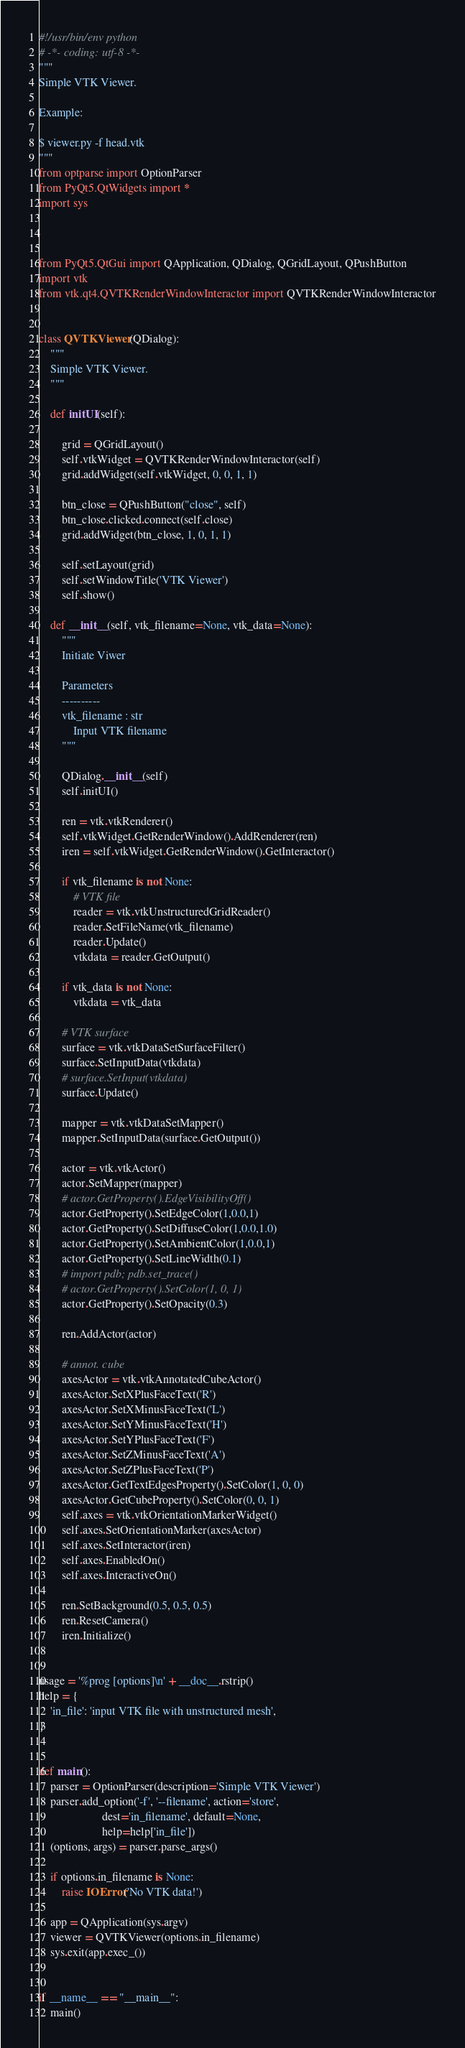Convert code to text. <code><loc_0><loc_0><loc_500><loc_500><_Python_>#!/usr/bin/env python
# -*- coding: utf-8 -*-
"""
Simple VTK Viewer.

Example:

$ viewer.py -f head.vtk
"""
from optparse import OptionParser
from PyQt5.QtWidgets import *
import sys



from PyQt5.QtGui import QApplication, QDialog, QGridLayout, QPushButton
import vtk
from vtk.qt4.QVTKRenderWindowInteractor import QVTKRenderWindowInteractor


class QVTKViewer(QDialog):
    """
    Simple VTK Viewer.
    """

    def initUI(self):

        grid = QGridLayout()
        self.vtkWidget = QVTKRenderWindowInteractor(self)
        grid.addWidget(self.vtkWidget, 0, 0, 1, 1)

        btn_close = QPushButton("close", self)
        btn_close.clicked.connect(self.close)
        grid.addWidget(btn_close, 1, 0, 1, 1)

        self.setLayout(grid)
        self.setWindowTitle('VTK Viewer')
        self.show()

    def __init__(self, vtk_filename=None, vtk_data=None):
        """
        Initiate Viwer

        Parameters
        ----------
        vtk_filename : str
            Input VTK filename
        """

        QDialog.__init__(self)
        self.initUI()

        ren = vtk.vtkRenderer()
        self.vtkWidget.GetRenderWindow().AddRenderer(ren)
        iren = self.vtkWidget.GetRenderWindow().GetInteractor()

        if vtk_filename is not None:
            # VTK file
            reader = vtk.vtkUnstructuredGridReader()
            reader.SetFileName(vtk_filename)
            reader.Update()
            vtkdata = reader.GetOutput()

        if vtk_data is not None:
            vtkdata = vtk_data

        # VTK surface
        surface = vtk.vtkDataSetSurfaceFilter()
        surface.SetInputData(vtkdata)
        # surface.SetInput(vtkdata)
        surface.Update()

        mapper = vtk.vtkDataSetMapper()
        mapper.SetInputData(surface.GetOutput())

        actor = vtk.vtkActor()
        actor.SetMapper(mapper)
        # actor.GetProperty().EdgeVisibilityOff()
        actor.GetProperty().SetEdgeColor(1,0.0,1)
        actor.GetProperty().SetDiffuseColor(1,0.0,1.0)
        actor.GetProperty().SetAmbientColor(1,0.0,1)
        actor.GetProperty().SetLineWidth(0.1)
        # import pdb; pdb.set_trace()
        # actor.GetProperty().SetColor(1, 0, 1)
        actor.GetProperty().SetOpacity(0.3)

        ren.AddActor(actor)

        # annot. cube
        axesActor = vtk.vtkAnnotatedCubeActor()
        axesActor.SetXPlusFaceText('R')
        axesActor.SetXMinusFaceText('L')
        axesActor.SetYMinusFaceText('H')
        axesActor.SetYPlusFaceText('F')
        axesActor.SetZMinusFaceText('A')
        axesActor.SetZPlusFaceText('P')
        axesActor.GetTextEdgesProperty().SetColor(1, 0, 0)
        axesActor.GetCubeProperty().SetColor(0, 0, 1)
        self.axes = vtk.vtkOrientationMarkerWidget()
        self.axes.SetOrientationMarker(axesActor)
        self.axes.SetInteractor(iren)
        self.axes.EnabledOn()
        self.axes.InteractiveOn()

        ren.SetBackground(0.5, 0.5, 0.5)
        ren.ResetCamera()
        iren.Initialize()


usage = '%prog [options]\n' + __doc__.rstrip()
help = {
    'in_file': 'input VTK file with unstructured mesh',
}


def main():
    parser = OptionParser(description='Simple VTK Viewer')
    parser.add_option('-f', '--filename', action='store',
                      dest='in_filename', default=None,
                      help=help['in_file'])
    (options, args) = parser.parse_args()

    if options.in_filename is None:
        raise IOError('No VTK data!')

    app = QApplication(sys.argv)
    viewer = QVTKViewer(options.in_filename)
    sys.exit(app.exec_())


if __name__ == "__main__":
    main()
</code> 